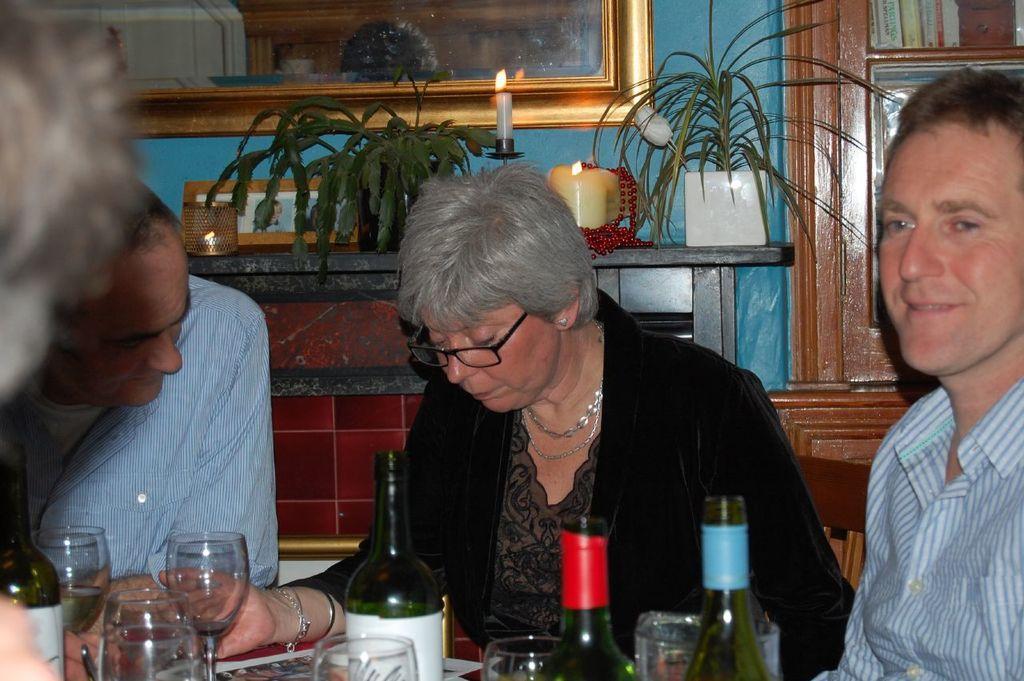Can you describe this image briefly? In image there are four people, there is a woman with black dress sitting in the middle of the two men. There are bottles, glasses on the table, at the backside of the women there is a candle and house plant, there is a photo frame on the wall. 